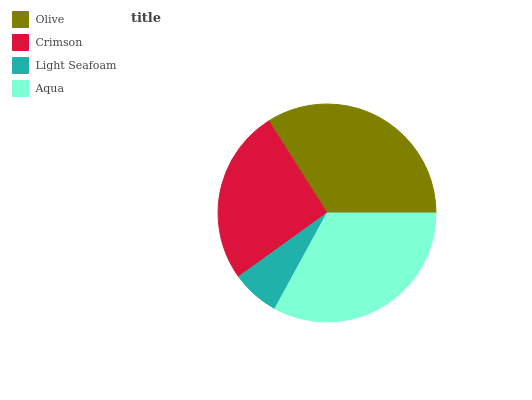Is Light Seafoam the minimum?
Answer yes or no. Yes. Is Olive the maximum?
Answer yes or no. Yes. Is Crimson the minimum?
Answer yes or no. No. Is Crimson the maximum?
Answer yes or no. No. Is Olive greater than Crimson?
Answer yes or no. Yes. Is Crimson less than Olive?
Answer yes or no. Yes. Is Crimson greater than Olive?
Answer yes or no. No. Is Olive less than Crimson?
Answer yes or no. No. Is Aqua the high median?
Answer yes or no. Yes. Is Crimson the low median?
Answer yes or no. Yes. Is Crimson the high median?
Answer yes or no. No. Is Aqua the low median?
Answer yes or no. No. 